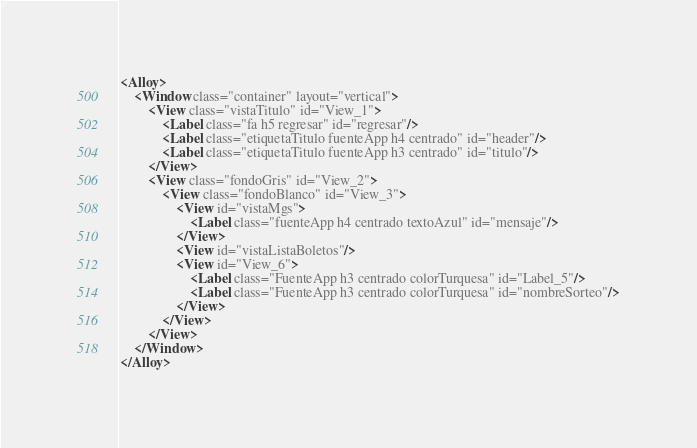Convert code to text. <code><loc_0><loc_0><loc_500><loc_500><_XML_><Alloy>
    <Window class="container" layout="vertical">
        <View class="vistaTitulo" id="View_1">
            <Label class="fa h5 regresar" id="regresar"/>
            <Label class="etiquetaTitulo fuenteApp h4 centrado" id="header"/>
            <Label class="etiquetaTitulo fuenteApp h3 centrado" id="titulo"/>
        </View>
        <View class="fondoGris" id="View_2">
            <View class="fondoBlanco" id="View_3">
                <View id="vistaMgs">
                    <Label class="fuenteApp h4 centrado textoAzul" id="mensaje"/>
                </View>
                <View id="vistaListaBoletos"/>
                <View id="View_6">
                    <Label class="FuenteApp h3 centrado colorTurquesa" id="Label_5"/>
                    <Label class="FuenteApp h3 centrado colorTurquesa" id="nombreSorteo"/>
                </View>
            </View>
        </View>
    </Window>
</Alloy>
</code> 